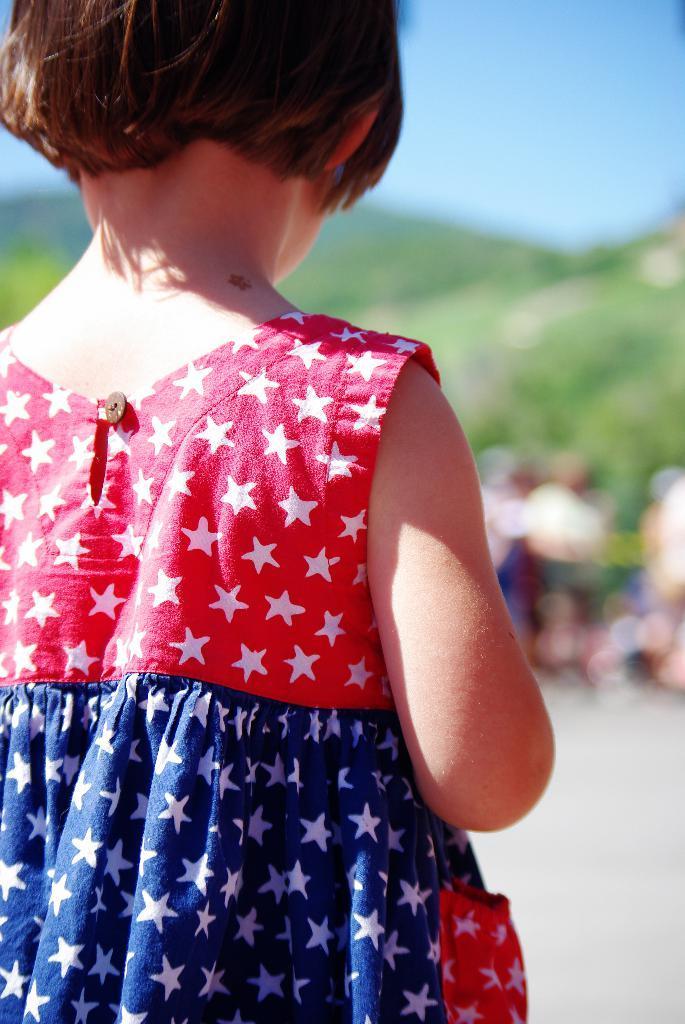Can you describe this image briefly? In picture there is a girl who is wearing red and blue color dress. In the back it might be the persons who are standing on the road. In the background I can see the mountains and trees. In the top right corner I can see the sky. 